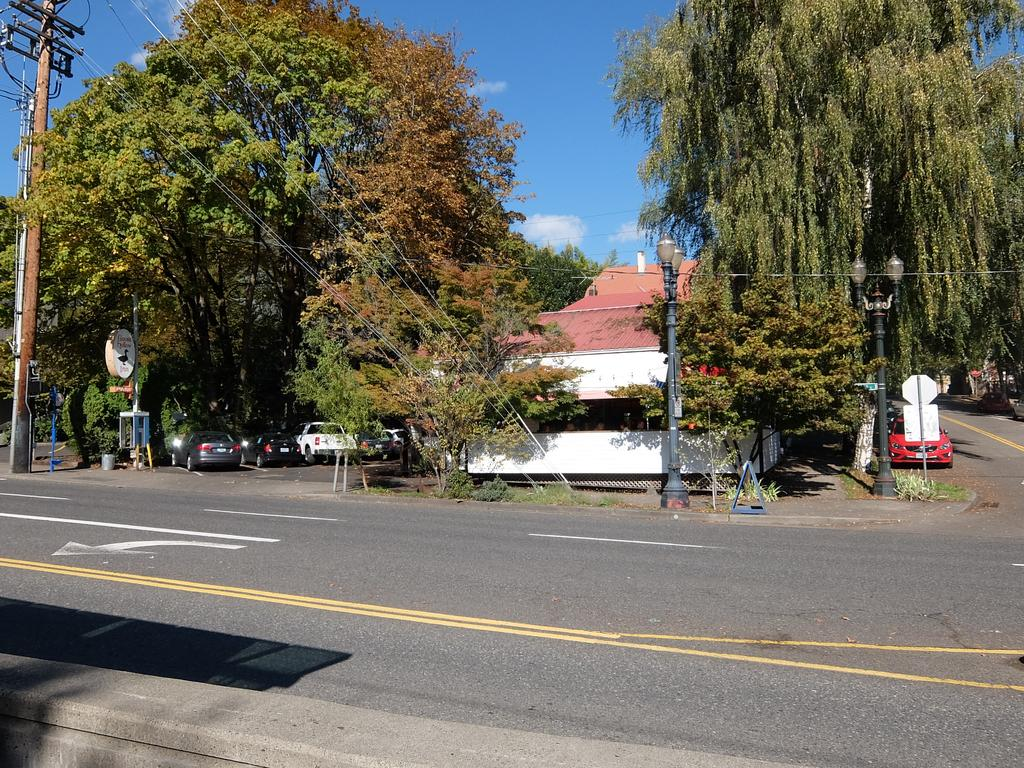What is visible in the foreground of the image? There is a road in the foreground of the image. What can be seen in the center of the image? There are trees, houses, cars, a pavement, street lights, a current pole, and a sign board in the center of the image. What type of weather is depicted in the image? The sky is sunny in the image. How can one make a payment for the sand in the image? There is no sand present in the image, so there is no need to make a payment for it. What type of transport is available for the transport of sand in the image? There is no sand or transport for sand in the image. 